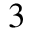<formula> <loc_0><loc_0><loc_500><loc_500>_ { 3 }</formula> 